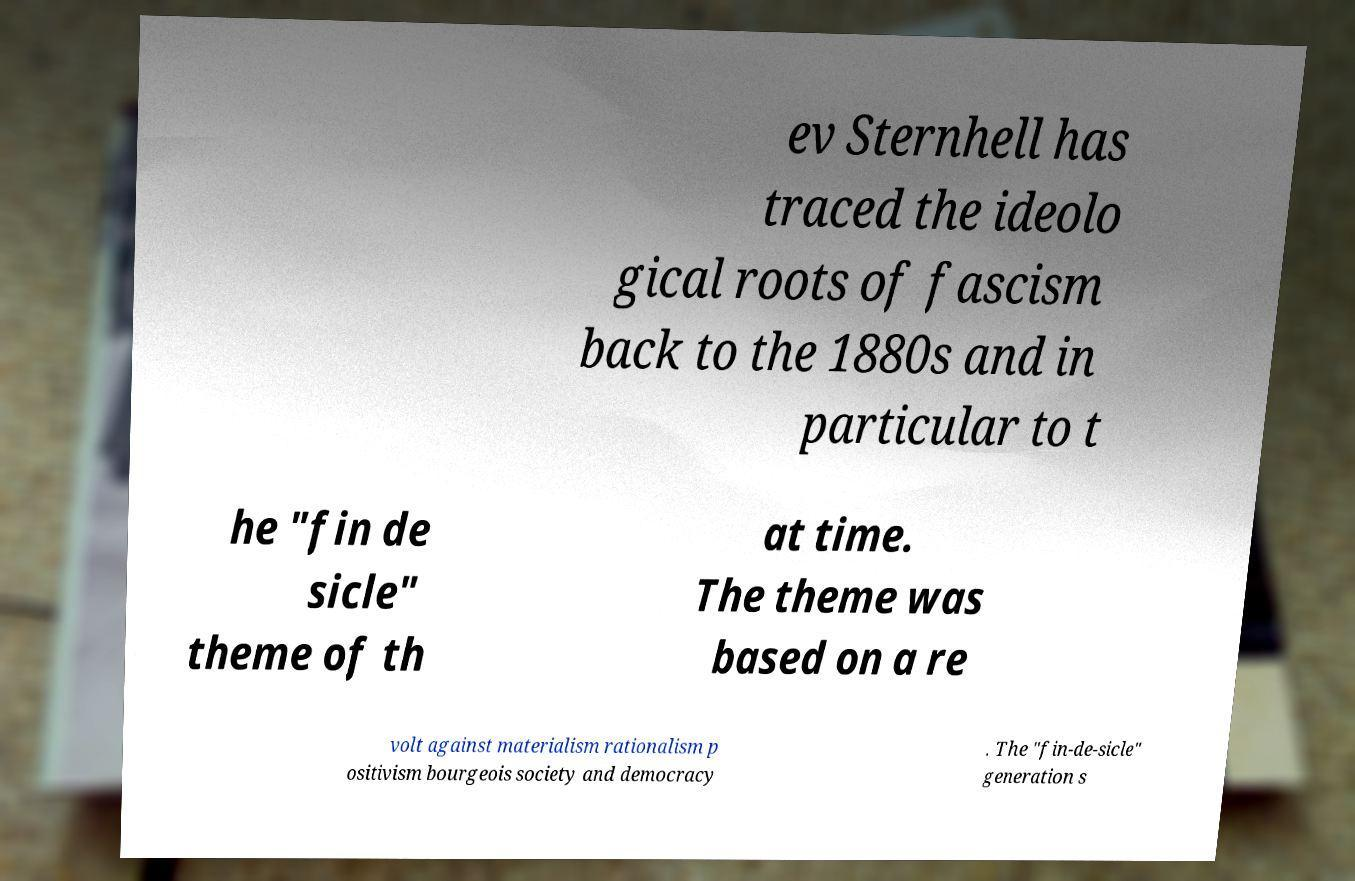Could you extract and type out the text from this image? ev Sternhell has traced the ideolo gical roots of fascism back to the 1880s and in particular to t he "fin de sicle" theme of th at time. The theme was based on a re volt against materialism rationalism p ositivism bourgeois society and democracy . The "fin-de-sicle" generation s 